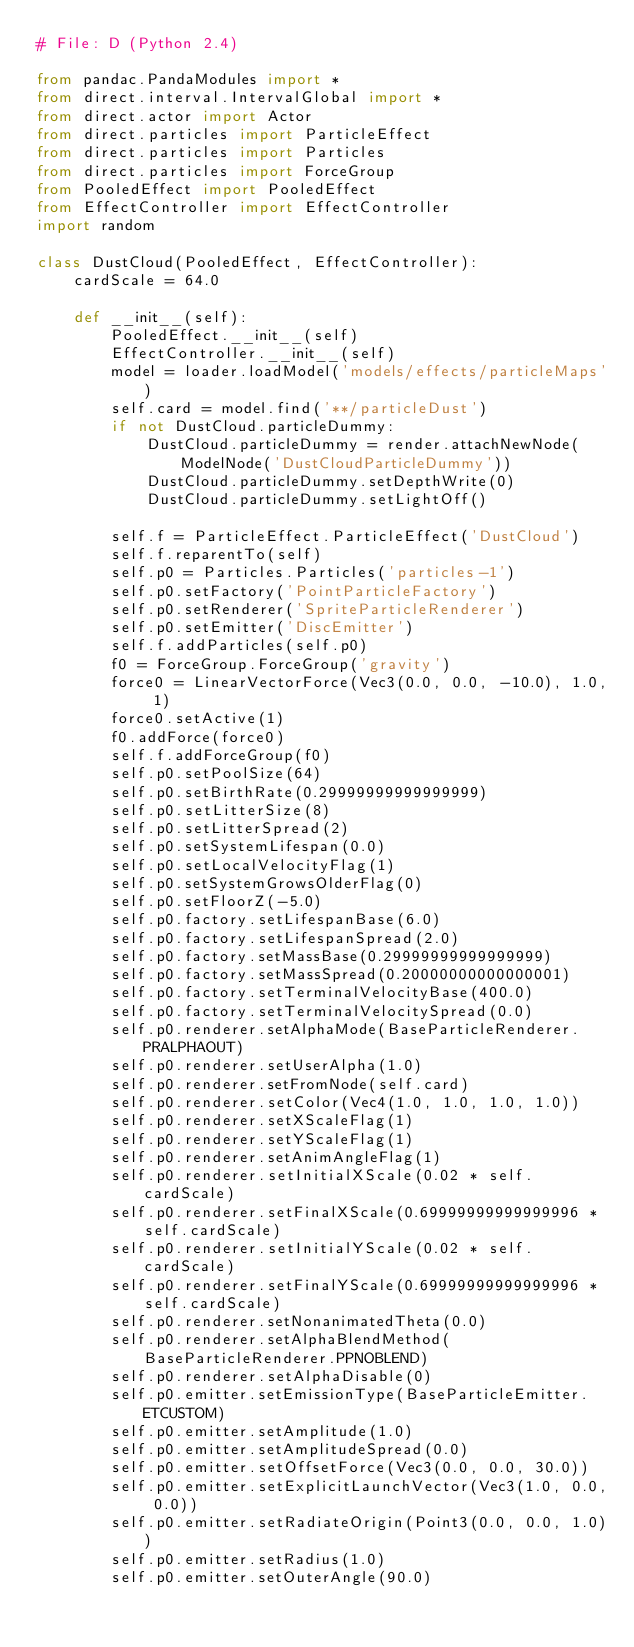<code> <loc_0><loc_0><loc_500><loc_500><_Python_># File: D (Python 2.4)

from pandac.PandaModules import *
from direct.interval.IntervalGlobal import *
from direct.actor import Actor
from direct.particles import ParticleEffect
from direct.particles import Particles
from direct.particles import ForceGroup
from PooledEffect import PooledEffect
from EffectController import EffectController
import random

class DustCloud(PooledEffect, EffectController):
    cardScale = 64.0
    
    def __init__(self):
        PooledEffect.__init__(self)
        EffectController.__init__(self)
        model = loader.loadModel('models/effects/particleMaps')
        self.card = model.find('**/particleDust')
        if not DustCloud.particleDummy:
            DustCloud.particleDummy = render.attachNewNode(ModelNode('DustCloudParticleDummy'))
            DustCloud.particleDummy.setDepthWrite(0)
            DustCloud.particleDummy.setLightOff()
        
        self.f = ParticleEffect.ParticleEffect('DustCloud')
        self.f.reparentTo(self)
        self.p0 = Particles.Particles('particles-1')
        self.p0.setFactory('PointParticleFactory')
        self.p0.setRenderer('SpriteParticleRenderer')
        self.p0.setEmitter('DiscEmitter')
        self.f.addParticles(self.p0)
        f0 = ForceGroup.ForceGroup('gravity')
        force0 = LinearVectorForce(Vec3(0.0, 0.0, -10.0), 1.0, 1)
        force0.setActive(1)
        f0.addForce(force0)
        self.f.addForceGroup(f0)
        self.p0.setPoolSize(64)
        self.p0.setBirthRate(0.29999999999999999)
        self.p0.setLitterSize(8)
        self.p0.setLitterSpread(2)
        self.p0.setSystemLifespan(0.0)
        self.p0.setLocalVelocityFlag(1)
        self.p0.setSystemGrowsOlderFlag(0)
        self.p0.setFloorZ(-5.0)
        self.p0.factory.setLifespanBase(6.0)
        self.p0.factory.setLifespanSpread(2.0)
        self.p0.factory.setMassBase(0.29999999999999999)
        self.p0.factory.setMassSpread(0.20000000000000001)
        self.p0.factory.setTerminalVelocityBase(400.0)
        self.p0.factory.setTerminalVelocitySpread(0.0)
        self.p0.renderer.setAlphaMode(BaseParticleRenderer.PRALPHAOUT)
        self.p0.renderer.setUserAlpha(1.0)
        self.p0.renderer.setFromNode(self.card)
        self.p0.renderer.setColor(Vec4(1.0, 1.0, 1.0, 1.0))
        self.p0.renderer.setXScaleFlag(1)
        self.p0.renderer.setYScaleFlag(1)
        self.p0.renderer.setAnimAngleFlag(1)
        self.p0.renderer.setInitialXScale(0.02 * self.cardScale)
        self.p0.renderer.setFinalXScale(0.69999999999999996 * self.cardScale)
        self.p0.renderer.setInitialYScale(0.02 * self.cardScale)
        self.p0.renderer.setFinalYScale(0.69999999999999996 * self.cardScale)
        self.p0.renderer.setNonanimatedTheta(0.0)
        self.p0.renderer.setAlphaBlendMethod(BaseParticleRenderer.PPNOBLEND)
        self.p0.renderer.setAlphaDisable(0)
        self.p0.emitter.setEmissionType(BaseParticleEmitter.ETCUSTOM)
        self.p0.emitter.setAmplitude(1.0)
        self.p0.emitter.setAmplitudeSpread(0.0)
        self.p0.emitter.setOffsetForce(Vec3(0.0, 0.0, 30.0))
        self.p0.emitter.setExplicitLaunchVector(Vec3(1.0, 0.0, 0.0))
        self.p0.emitter.setRadiateOrigin(Point3(0.0, 0.0, 1.0))
        self.p0.emitter.setRadius(1.0)
        self.p0.emitter.setOuterAngle(90.0)</code> 